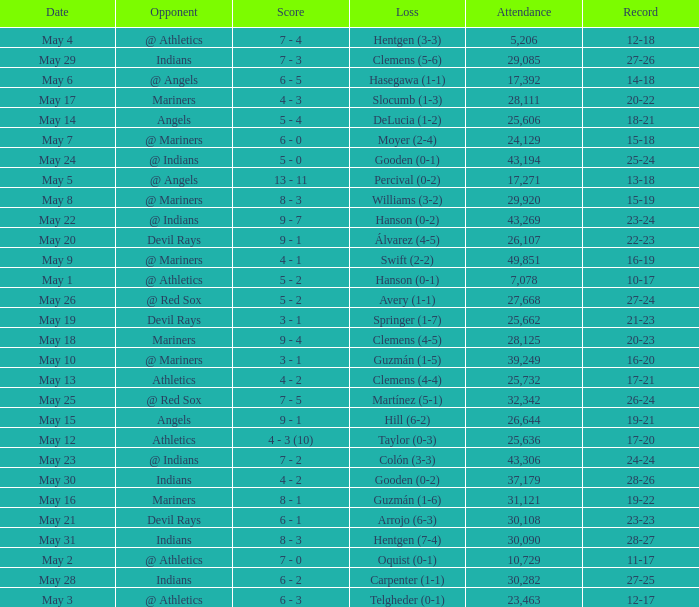For record 25-24, what is the sum of attendance? 1.0. 